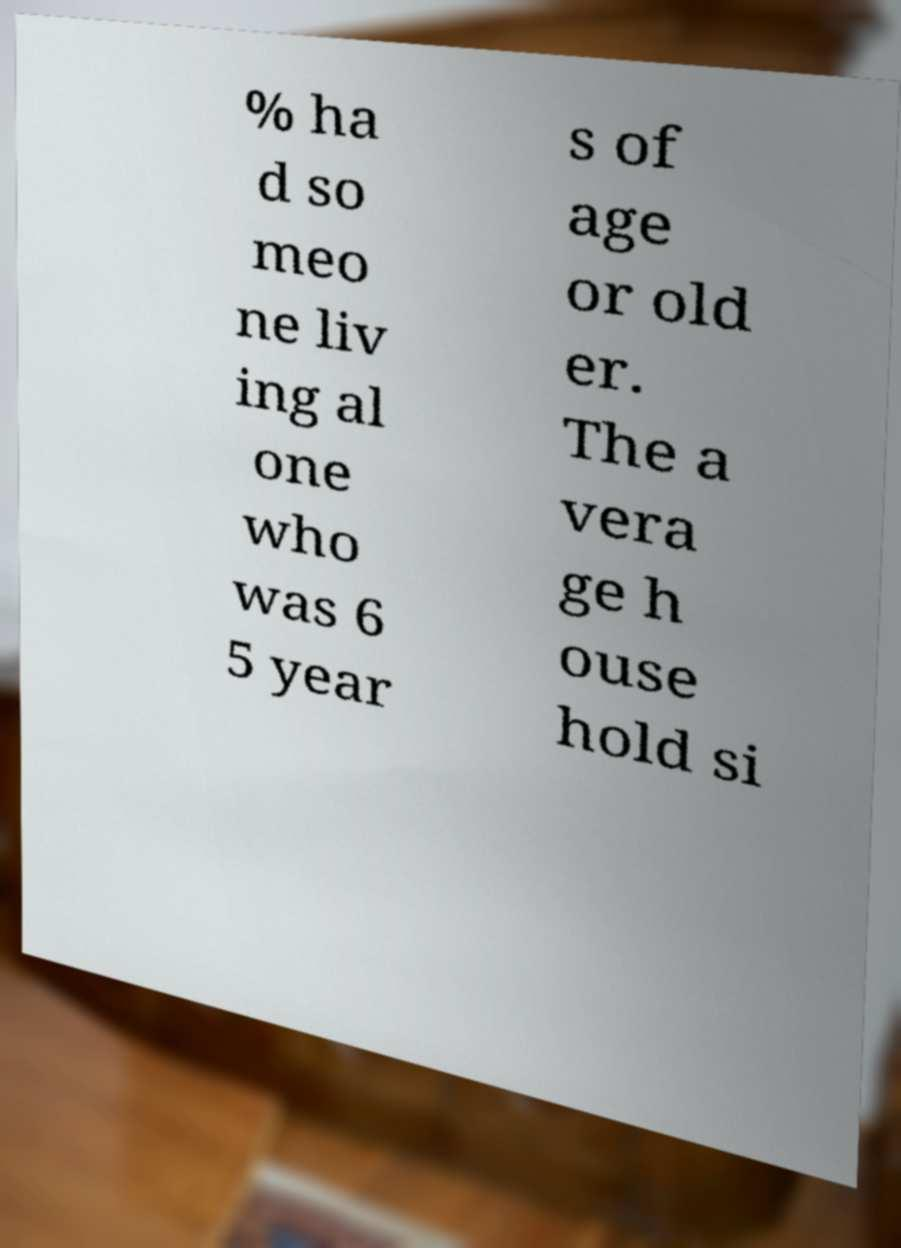What messages or text are displayed in this image? I need them in a readable, typed format. % ha d so meo ne liv ing al one who was 6 5 year s of age or old er. The a vera ge h ouse hold si 